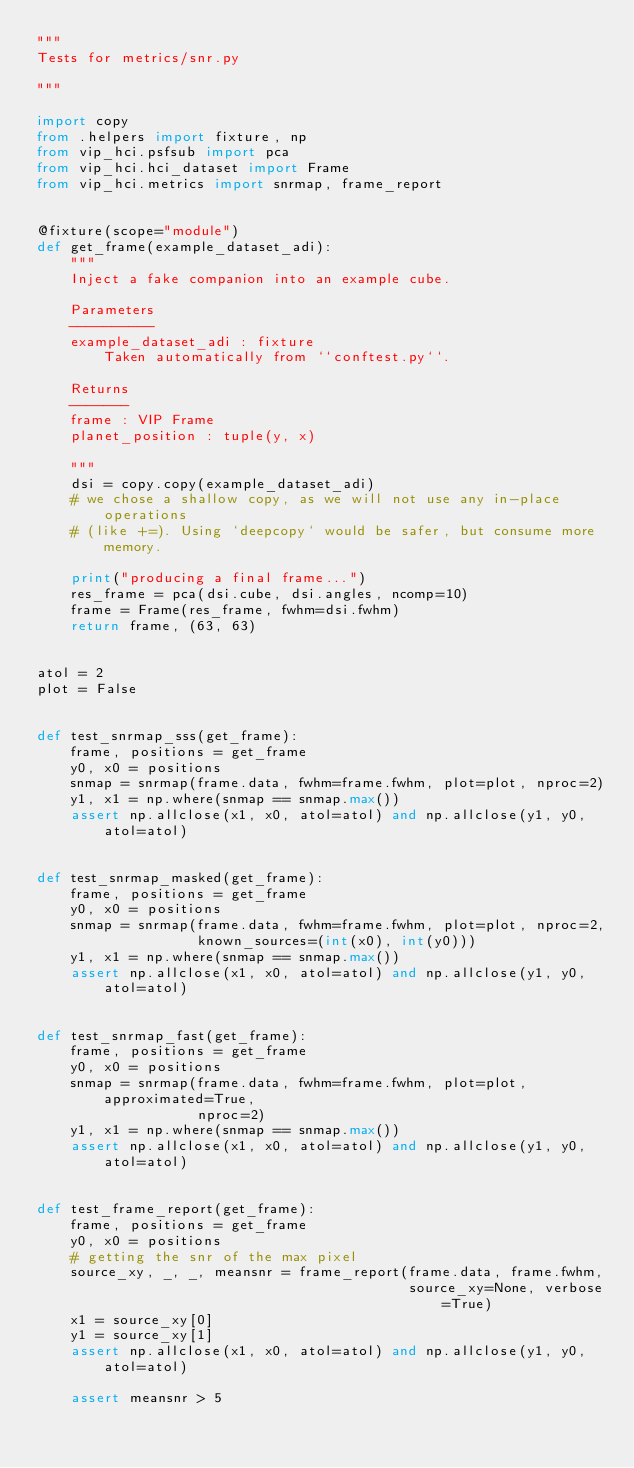<code> <loc_0><loc_0><loc_500><loc_500><_Python_>"""
Tests for metrics/snr.py

"""

import copy
from .helpers import fixture, np
from vip_hci.psfsub import pca
from vip_hci.hci_dataset import Frame
from vip_hci.metrics import snrmap, frame_report


@fixture(scope="module")
def get_frame(example_dataset_adi):
    """
    Inject a fake companion into an example cube.

    Parameters
    ----------
    example_dataset_adi : fixture
        Taken automatically from ``conftest.py``.

    Returns
    -------
    frame : VIP Frame
    planet_position : tuple(y, x)

    """
    dsi = copy.copy(example_dataset_adi)
    # we chose a shallow copy, as we will not use any in-place operations
    # (like +=). Using `deepcopy` would be safer, but consume more memory.

    print("producing a final frame...")
    res_frame = pca(dsi.cube, dsi.angles, ncomp=10)
    frame = Frame(res_frame, fwhm=dsi.fwhm)
    return frame, (63, 63)


atol = 2
plot = False


def test_snrmap_sss(get_frame):
    frame, positions = get_frame
    y0, x0 = positions
    snmap = snrmap(frame.data, fwhm=frame.fwhm, plot=plot, nproc=2)
    y1, x1 = np.where(snmap == snmap.max())
    assert np.allclose(x1, x0, atol=atol) and np.allclose(y1, y0, atol=atol)


def test_snrmap_masked(get_frame):
    frame, positions = get_frame
    y0, x0 = positions
    snmap = snrmap(frame.data, fwhm=frame.fwhm, plot=plot, nproc=2,
                   known_sources=(int(x0), int(y0)))
    y1, x1 = np.where(snmap == snmap.max())
    assert np.allclose(x1, x0, atol=atol) and np.allclose(y1, y0, atol=atol)


def test_snrmap_fast(get_frame):
    frame, positions = get_frame
    y0, x0 = positions
    snmap = snrmap(frame.data, fwhm=frame.fwhm, plot=plot, approximated=True,
                   nproc=2)
    y1, x1 = np.where(snmap == snmap.max())
    assert np.allclose(x1, x0, atol=atol) and np.allclose(y1, y0, atol=atol)

        
def test_frame_report(get_frame):
    frame, positions = get_frame
    y0, x0 = positions
    # getting the snr of the max pixel
    source_xy, _, _, meansnr = frame_report(frame.data, frame.fwhm,
                                            source_xy=None, verbose=True)
    x1 = source_xy[0]
    y1 = source_xy[1]
    assert np.allclose(x1, x0, atol=atol) and np.allclose(y1, y0, atol=atol)

    assert meansnr > 5
</code> 